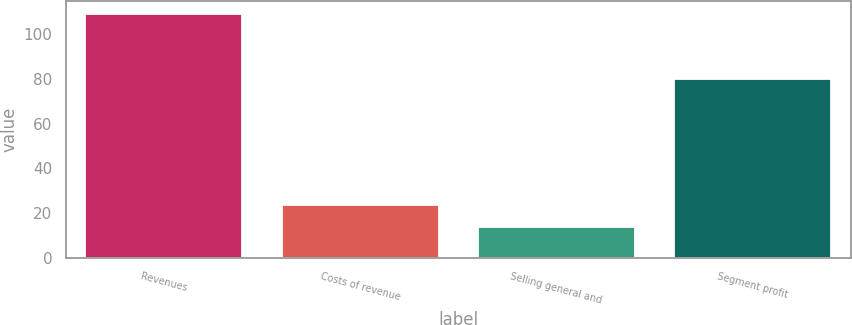Convert chart to OTSL. <chart><loc_0><loc_0><loc_500><loc_500><bar_chart><fcel>Revenues<fcel>Costs of revenue<fcel>Selling general and<fcel>Segment profit<nl><fcel>109<fcel>23.5<fcel>14<fcel>80<nl></chart> 